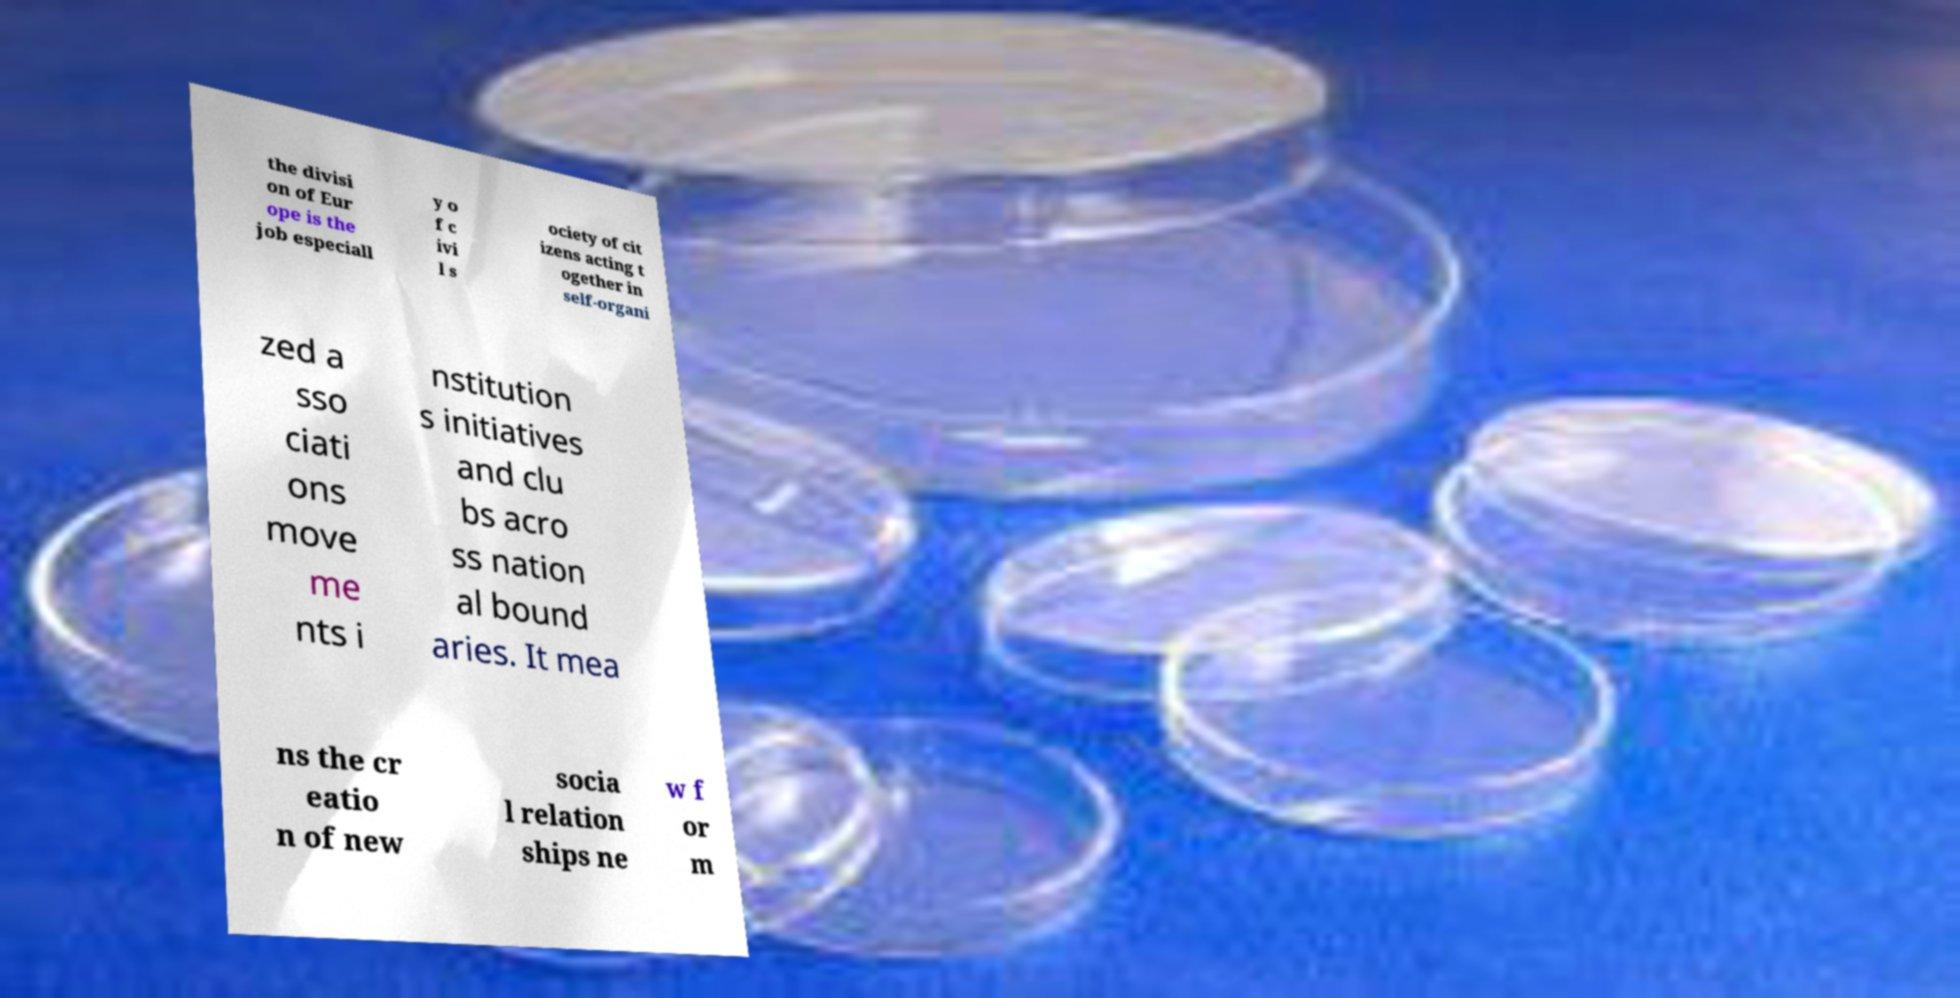For documentation purposes, I need the text within this image transcribed. Could you provide that? the divisi on of Eur ope is the job especiall y o f c ivi l s ociety of cit izens acting t ogether in self-organi zed a sso ciati ons move me nts i nstitution s initiatives and clu bs acro ss nation al bound aries. It mea ns the cr eatio n of new socia l relation ships ne w f or m 